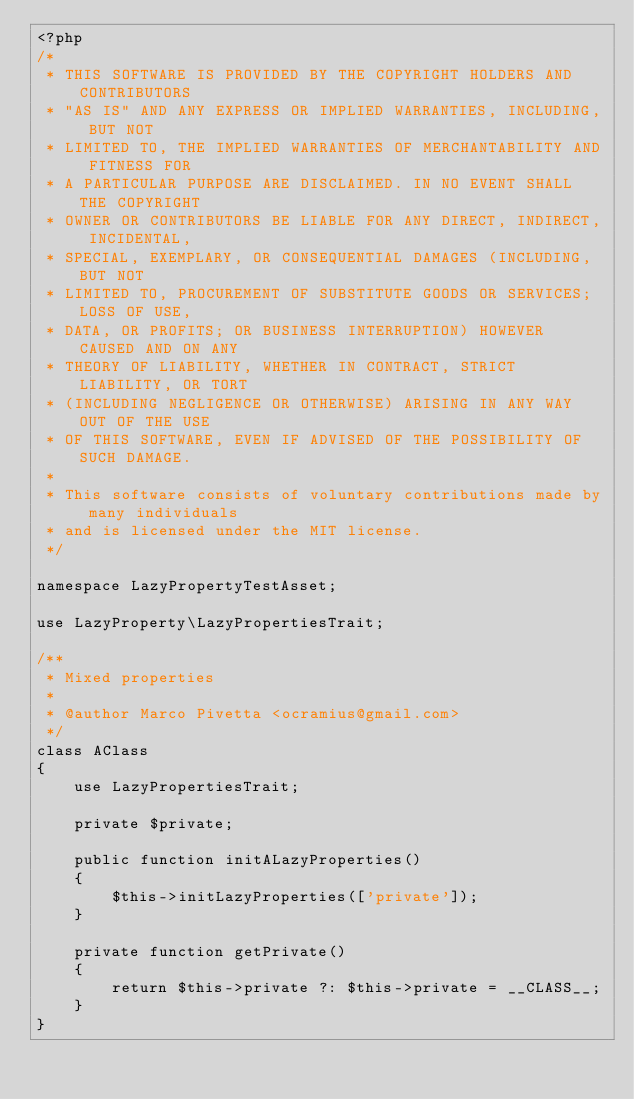Convert code to text. <code><loc_0><loc_0><loc_500><loc_500><_PHP_><?php
/*
 * THIS SOFTWARE IS PROVIDED BY THE COPYRIGHT HOLDERS AND CONTRIBUTORS
 * "AS IS" AND ANY EXPRESS OR IMPLIED WARRANTIES, INCLUDING, BUT NOT
 * LIMITED TO, THE IMPLIED WARRANTIES OF MERCHANTABILITY AND FITNESS FOR
 * A PARTICULAR PURPOSE ARE DISCLAIMED. IN NO EVENT SHALL THE COPYRIGHT
 * OWNER OR CONTRIBUTORS BE LIABLE FOR ANY DIRECT, INDIRECT, INCIDENTAL,
 * SPECIAL, EXEMPLARY, OR CONSEQUENTIAL DAMAGES (INCLUDING, BUT NOT
 * LIMITED TO, PROCUREMENT OF SUBSTITUTE GOODS OR SERVICES; LOSS OF USE,
 * DATA, OR PROFITS; OR BUSINESS INTERRUPTION) HOWEVER CAUSED AND ON ANY
 * THEORY OF LIABILITY, WHETHER IN CONTRACT, STRICT LIABILITY, OR TORT
 * (INCLUDING NEGLIGENCE OR OTHERWISE) ARISING IN ANY WAY OUT OF THE USE
 * OF THIS SOFTWARE, EVEN IF ADVISED OF THE POSSIBILITY OF SUCH DAMAGE.
 *
 * This software consists of voluntary contributions made by many individuals
 * and is licensed under the MIT license.
 */

namespace LazyPropertyTestAsset;

use LazyProperty\LazyPropertiesTrait;

/**
 * Mixed properties
 *
 * @author Marco Pivetta <ocramius@gmail.com>
 */
class AClass
{
    use LazyPropertiesTrait;

    private $private;

    public function initALazyProperties()
    {
        $this->initLazyProperties(['private']);
    }

    private function getPrivate()
    {
        return $this->private ?: $this->private = __CLASS__;
    }
}
</code> 